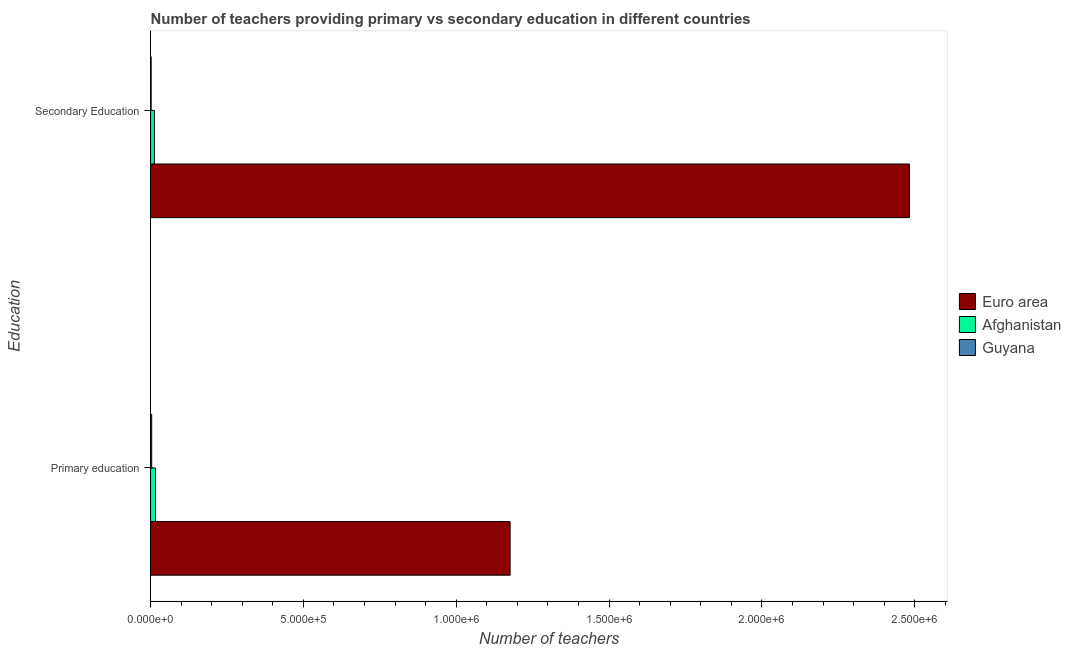How many different coloured bars are there?
Keep it short and to the point. 3. Are the number of bars per tick equal to the number of legend labels?
Ensure brevity in your answer.  Yes. What is the label of the 1st group of bars from the top?
Offer a very short reply. Secondary Education. What is the number of primary teachers in Afghanistan?
Ensure brevity in your answer.  1.62e+04. Across all countries, what is the maximum number of primary teachers?
Offer a terse response. 1.18e+06. Across all countries, what is the minimum number of primary teachers?
Give a very brief answer. 3669. In which country was the number of primary teachers minimum?
Your answer should be very brief. Guyana. What is the total number of secondary teachers in the graph?
Provide a succinct answer. 2.50e+06. What is the difference between the number of primary teachers in Guyana and that in Euro area?
Your response must be concise. -1.17e+06. What is the difference between the number of primary teachers in Afghanistan and the number of secondary teachers in Euro area?
Your answer should be very brief. -2.47e+06. What is the average number of secondary teachers per country?
Offer a very short reply. 8.32e+05. What is the difference between the number of secondary teachers and number of primary teachers in Afghanistan?
Offer a very short reply. -3712. In how many countries, is the number of primary teachers greater than 1800000 ?
Your response must be concise. 0. What is the ratio of the number of primary teachers in Afghanistan to that in Guyana?
Offer a very short reply. 4.4. Is the number of primary teachers in Guyana less than that in Afghanistan?
Your response must be concise. Yes. What does the 2nd bar from the top in Primary education represents?
Offer a terse response. Afghanistan. What does the 2nd bar from the bottom in Secondary Education represents?
Give a very brief answer. Afghanistan. Are all the bars in the graph horizontal?
Ensure brevity in your answer.  Yes. How many countries are there in the graph?
Keep it short and to the point. 3. Where does the legend appear in the graph?
Offer a very short reply. Center right. How many legend labels are there?
Offer a terse response. 3. What is the title of the graph?
Keep it short and to the point. Number of teachers providing primary vs secondary education in different countries. What is the label or title of the X-axis?
Offer a terse response. Number of teachers. What is the label or title of the Y-axis?
Offer a very short reply. Education. What is the Number of teachers of Euro area in Primary education?
Offer a terse response. 1.18e+06. What is the Number of teachers of Afghanistan in Primary education?
Make the answer very short. 1.62e+04. What is the Number of teachers in Guyana in Primary education?
Make the answer very short. 3669. What is the Number of teachers in Euro area in Secondary Education?
Provide a succinct answer. 2.48e+06. What is the Number of teachers of Afghanistan in Secondary Education?
Ensure brevity in your answer.  1.24e+04. What is the Number of teachers in Guyana in Secondary Education?
Provide a succinct answer. 1859. Across all Education, what is the maximum Number of teachers in Euro area?
Provide a succinct answer. 2.48e+06. Across all Education, what is the maximum Number of teachers of Afghanistan?
Provide a succinct answer. 1.62e+04. Across all Education, what is the maximum Number of teachers in Guyana?
Keep it short and to the point. 3669. Across all Education, what is the minimum Number of teachers in Euro area?
Make the answer very short. 1.18e+06. Across all Education, what is the minimum Number of teachers of Afghanistan?
Provide a short and direct response. 1.24e+04. Across all Education, what is the minimum Number of teachers of Guyana?
Keep it short and to the point. 1859. What is the total Number of teachers in Euro area in the graph?
Your response must be concise. 3.66e+06. What is the total Number of teachers of Afghanistan in the graph?
Provide a succinct answer. 2.86e+04. What is the total Number of teachers of Guyana in the graph?
Offer a very short reply. 5528. What is the difference between the Number of teachers of Euro area in Primary education and that in Secondary Education?
Your answer should be compact. -1.31e+06. What is the difference between the Number of teachers of Afghanistan in Primary education and that in Secondary Education?
Your response must be concise. 3712. What is the difference between the Number of teachers in Guyana in Primary education and that in Secondary Education?
Provide a succinct answer. 1810. What is the difference between the Number of teachers of Euro area in Primary education and the Number of teachers of Afghanistan in Secondary Education?
Your answer should be very brief. 1.16e+06. What is the difference between the Number of teachers in Euro area in Primary education and the Number of teachers in Guyana in Secondary Education?
Keep it short and to the point. 1.17e+06. What is the difference between the Number of teachers of Afghanistan in Primary education and the Number of teachers of Guyana in Secondary Education?
Your response must be concise. 1.43e+04. What is the average Number of teachers in Euro area per Education?
Offer a terse response. 1.83e+06. What is the average Number of teachers in Afghanistan per Education?
Your answer should be compact. 1.43e+04. What is the average Number of teachers of Guyana per Education?
Make the answer very short. 2764. What is the difference between the Number of teachers in Euro area and Number of teachers in Afghanistan in Primary education?
Keep it short and to the point. 1.16e+06. What is the difference between the Number of teachers of Euro area and Number of teachers of Guyana in Primary education?
Make the answer very short. 1.17e+06. What is the difference between the Number of teachers of Afghanistan and Number of teachers of Guyana in Primary education?
Offer a very short reply. 1.25e+04. What is the difference between the Number of teachers of Euro area and Number of teachers of Afghanistan in Secondary Education?
Ensure brevity in your answer.  2.47e+06. What is the difference between the Number of teachers of Euro area and Number of teachers of Guyana in Secondary Education?
Your answer should be very brief. 2.48e+06. What is the difference between the Number of teachers of Afghanistan and Number of teachers of Guyana in Secondary Education?
Your response must be concise. 1.06e+04. What is the ratio of the Number of teachers in Euro area in Primary education to that in Secondary Education?
Offer a very short reply. 0.47. What is the ratio of the Number of teachers of Afghanistan in Primary education to that in Secondary Education?
Make the answer very short. 1.3. What is the ratio of the Number of teachers in Guyana in Primary education to that in Secondary Education?
Keep it short and to the point. 1.97. What is the difference between the highest and the second highest Number of teachers of Euro area?
Provide a short and direct response. 1.31e+06. What is the difference between the highest and the second highest Number of teachers of Afghanistan?
Provide a short and direct response. 3712. What is the difference between the highest and the second highest Number of teachers of Guyana?
Give a very brief answer. 1810. What is the difference between the highest and the lowest Number of teachers in Euro area?
Give a very brief answer. 1.31e+06. What is the difference between the highest and the lowest Number of teachers in Afghanistan?
Ensure brevity in your answer.  3712. What is the difference between the highest and the lowest Number of teachers of Guyana?
Provide a short and direct response. 1810. 